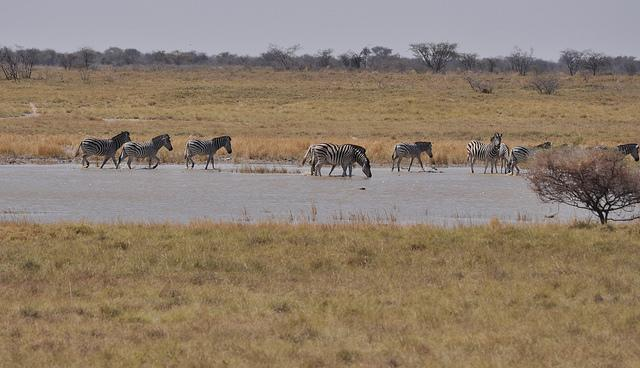What are the zebras all standing inside of? water 